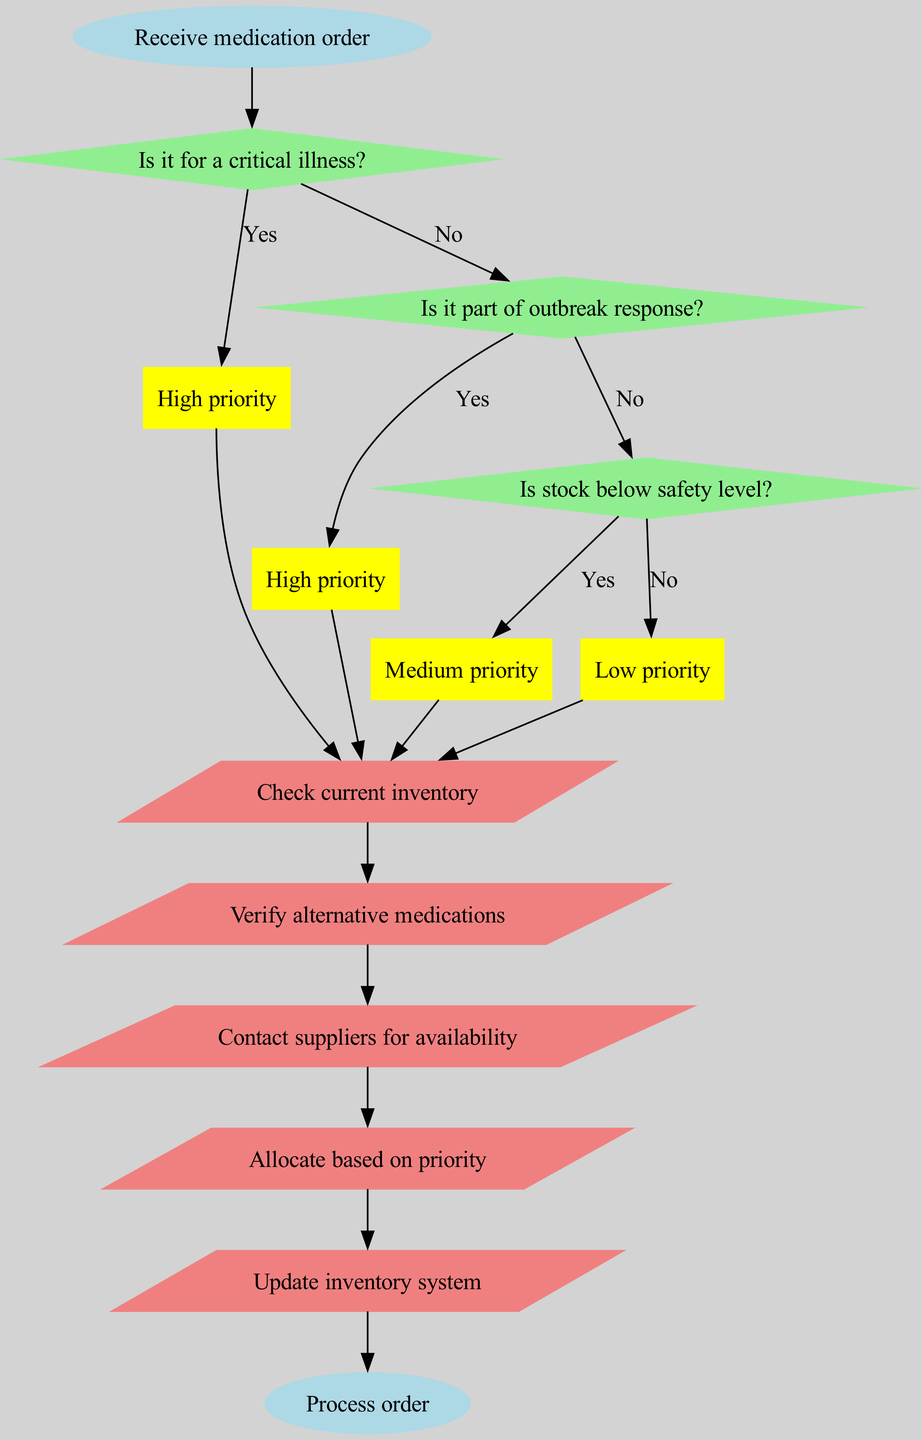What is the starting point of the flowchart? The flowchart begins with the node labeled "Receive medication order," which indicates the initial action to take when a medication order is received.
Answer: Receive medication order How many decision nodes are present in the diagram? There are three decision nodes that evaluate different conditions related to medication orders during supply shortages.
Answer: 3 What action follows the node indicating "High priority"? After the "High priority" node, the first action taken is to "Check current inventory," which is the next step after determining the priority level of the medication order.
Answer: Check current inventory What condition leads to a "Medium priority"? The "Is stock below safety level?" decision node leads to a "Medium priority" if the answer to the condition is "Yes," indicating that inventory must be monitored closely.
Answer: Is stock below safety level? If an order is not for a critical illness, what is the next step in the flowchart? If the order is not for a critical illness, the flowchart directs the user to check the next decision condition, which is whether the order is part of an outbreak response.
Answer: Check next condition Under what condition does the flowchart determine "Low priority"? The flowchart determines "Low priority" when both the conditions about critical illness and outbreak response are answered "No," as well as if the stock is not below safety level.
Answer: No critical illness, no outbreak response, stock not below safety level What action is designated to "Allocate based on priority"? This action occurs after assessing the priority levels of medication orders, and it aims to allocate the available medications accordingly to ensure effectiveness in response to supply shortages.
Answer: Allocate based on priority Which decision node is positioned last in the flowchart? The last decision node is "Is stock below safety level?", which evaluates the inventory situation after the earlier priority checks have been conducted.
Answer: Is stock below safety level What is the endpoint of the flowchart? The flowchart concludes with the final action of processing the order, labeled as "Process order," indicating the end of the decision-making sequence.
Answer: Process order 